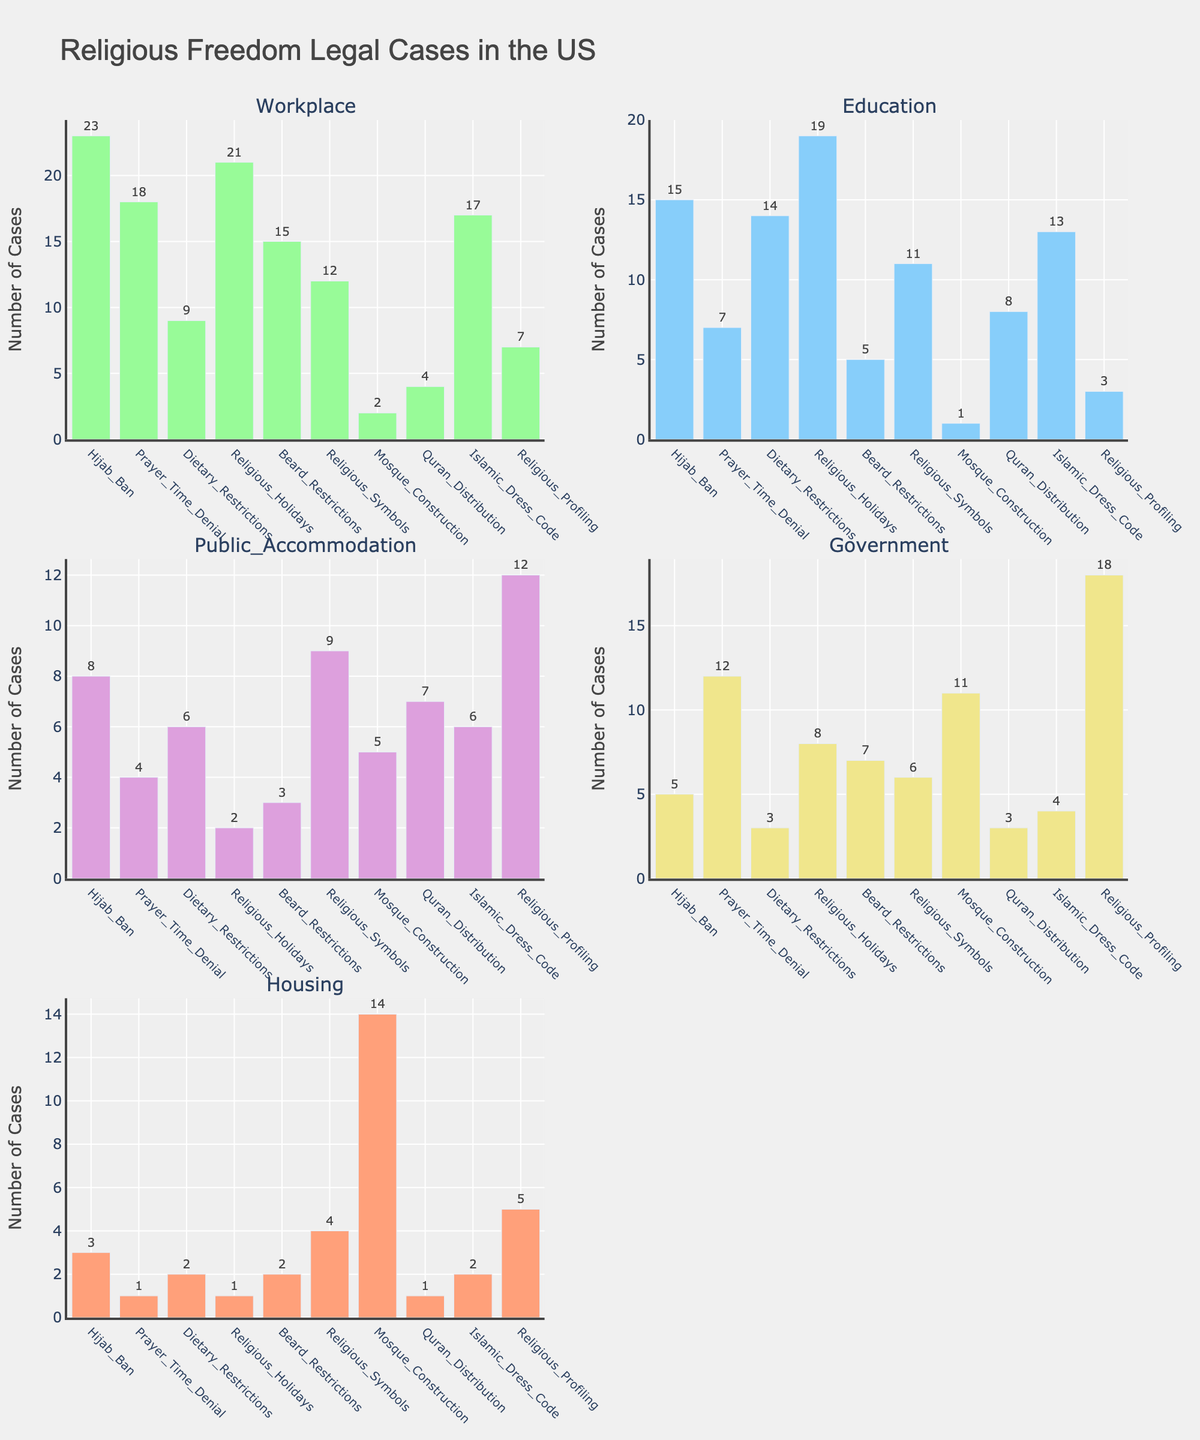Which case type has the highest number of cases in the Workplace category? In the Workplace category subplot, the bar representing 'Hijab Ban' is the tallest, indicating it has the highest number of cases.
Answer: Hijab Ban How many total cases are in the Government category? To find the total number of cases in the Government category, sum the values of all corresponding bars: 5 (Hijab Ban) + 12 (Prayer Time Denial) + 3 (Dietary Restrictions) + 8 (Religious Holidays) + 7 (Beard Restrictions) + 6 (Religious Symbols) + 11 (Mosque Construction) + 3 (Quran Distribution) + 4 (Islamic Dress Code) + 18 (Religious Profiling). The total is 77.
Answer: 77 What is the difference between the number of cases related to 'Dietary Restrictions' in Education and in Public Accommodation? In the Education category, 'Dietary Restrictions' has 14 cases, and in the Public Accommodation category, it has 6 cases. The difference is 14 - 6 = 8.
Answer: 8 Which category has the least number of cases for 'Islamic Dress Code'? Look across the subplots for the bars representing 'Islamic Dress Code.' The Housing category has the shortest bar, indicating it has the least number of cases, which is 2.
Answer: Housing Among the 'Mosque Construction' cases, which category has the second highest number of cases? In the 'Mosque Construction' subplot, the Education category has 1 case, Public Accommodation has 5, Government has 11, Housing has 14, and Workplace has 2. The second highest number is in the Government category with 11 cases.
Answer: Government How many categories have more than 10 cases of 'Religious Holidays' discrimination? For 'Religious Holidays,' check each subplot to find categories with more than 10 cases: Workplace (21), Education (19), and Government (8). Only 2 categories have more than 10 cases: Workplace and Education.
Answer: 2 Which case types have more than 10 cases in Housing? In the Housing category subplot, the bars above 10 are 'Mosque Construction' with 14 cases and 'Religious Profiling' with 5 cases. Only 'Mosque Construction' has more than 10 cases.
Answer: Mosque Construction What is the sum of all cases for 'Beard Restrictions' across all categories? To find the sum, add the values for 'Beard Restrictions' across the subplots: 15 (Workplace) + 5 (Education) + 3 (Public Accommodation) + 7 (Government) + 2 (Housing). The total is 15 + 5 + 3 + 7 + 2 = 32.
Answer: 32 Which category has the highest number of cases for 'Prayer Time Denial'? In the 'Prayer Time Denial' subplot, the highest bar is in the Government category, which has 12 cases.
Answer: Government 